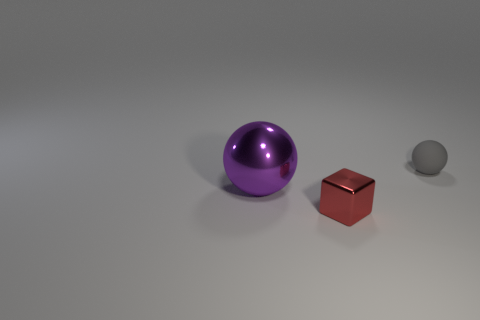There is a object behind the big purple ball; what is its material?
Offer a very short reply. Rubber. Are there an equal number of red metallic cubes that are behind the red metallic cube and things?
Your response must be concise. No. Is there anything else that has the same size as the purple metallic thing?
Keep it short and to the point. No. There is a ball that is on the left side of the tiny object in front of the tiny gray thing; what is it made of?
Your response must be concise. Metal. There is a thing that is right of the purple ball and to the left of the tiny sphere; what is its shape?
Your answer should be very brief. Cube. There is a gray rubber thing that is the same shape as the large purple metallic object; what size is it?
Keep it short and to the point. Small. Are there fewer red metal cubes on the left side of the purple sphere than brown rubber things?
Offer a very short reply. No. What size is the thing to the left of the red cube?
Provide a succinct answer. Large. There is a big thing that is the same shape as the small matte object; what color is it?
Your response must be concise. Purple. What number of other tiny rubber objects are the same color as the small matte object?
Provide a short and direct response. 0. 